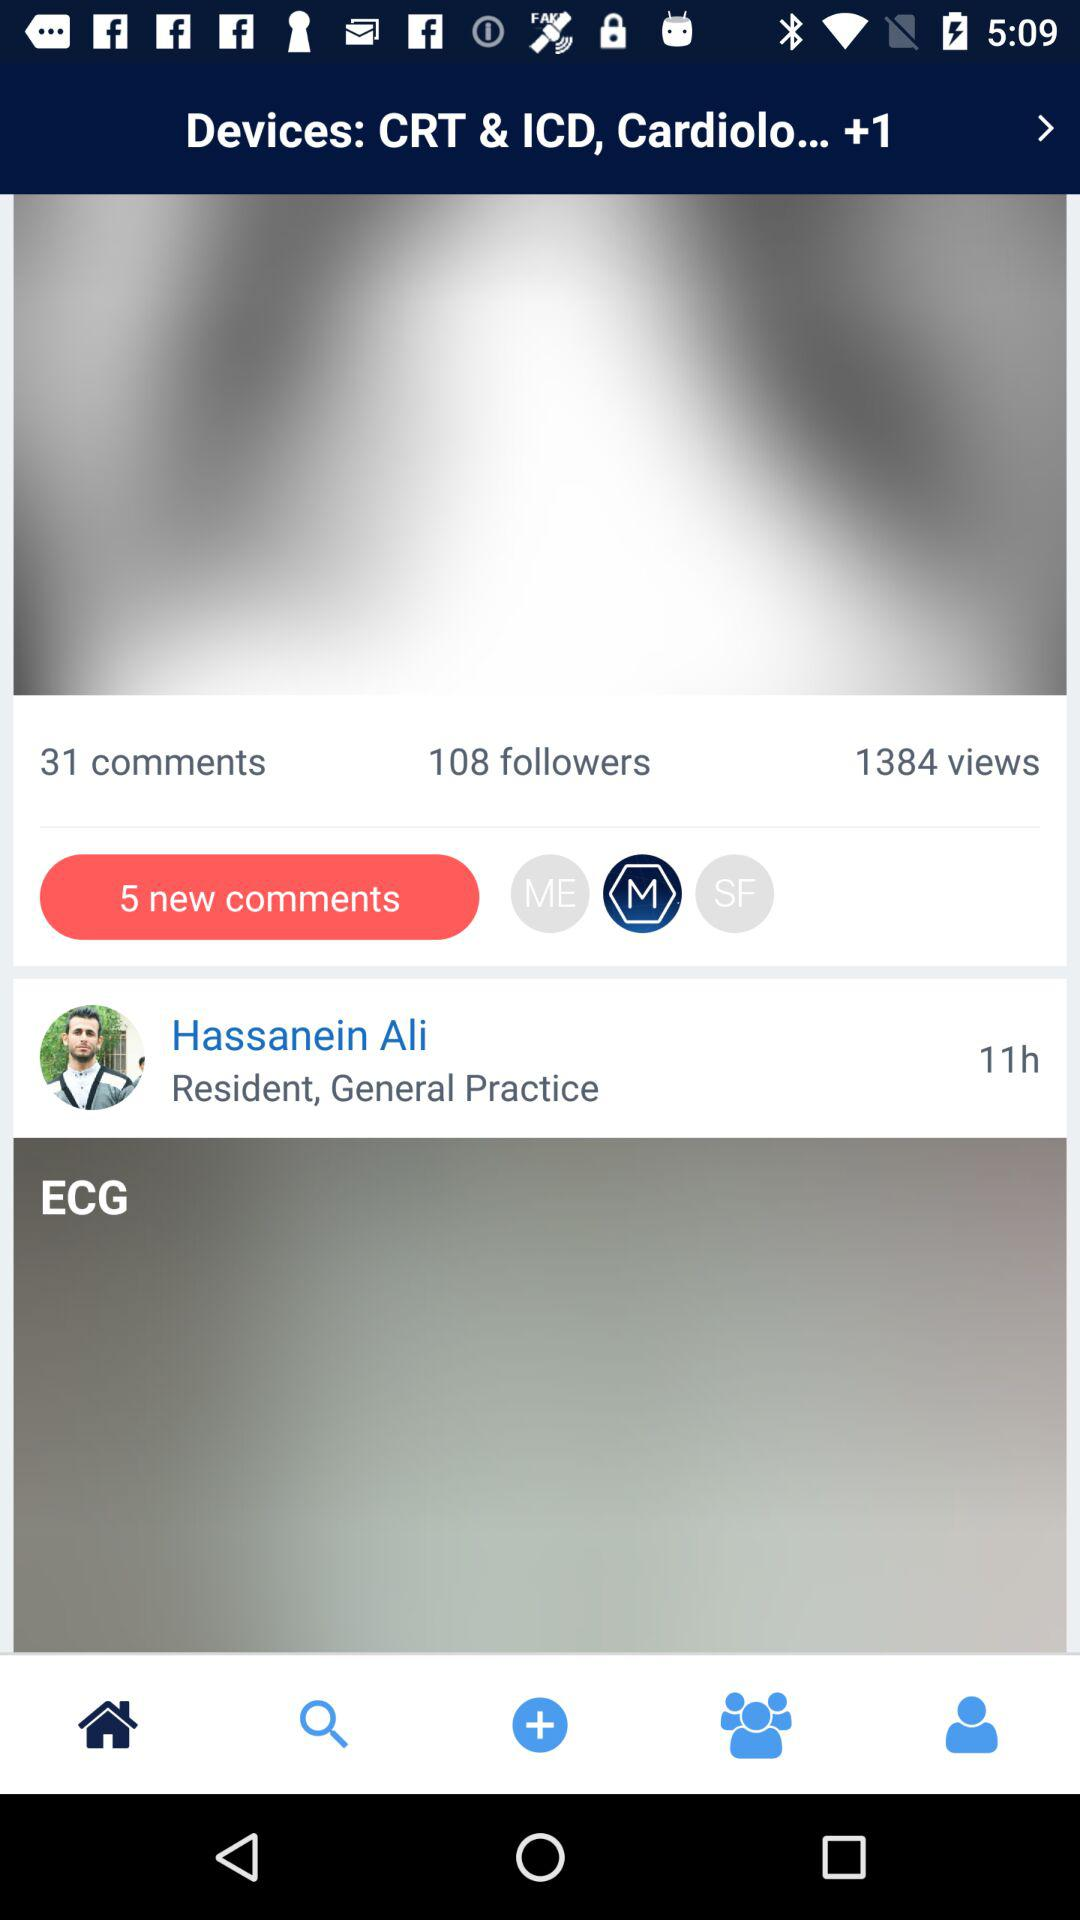How many followers are shown on the screen? There are 108 followers shown on the screen. 